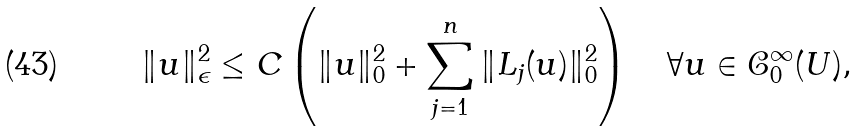Convert formula to latex. <formula><loc_0><loc_0><loc_500><loc_500>\| u \| _ { \epsilon } ^ { 2 } \leq { C } \left ( \| u \| ^ { 2 } _ { 0 } + \sum _ { j = 1 } ^ { n } \| L _ { j } ( u ) \| _ { 0 } ^ { 2 } \right ) \quad \forall { u } \in \mathcal { C } ^ { \infty } _ { 0 } ( U ) ,</formula> 